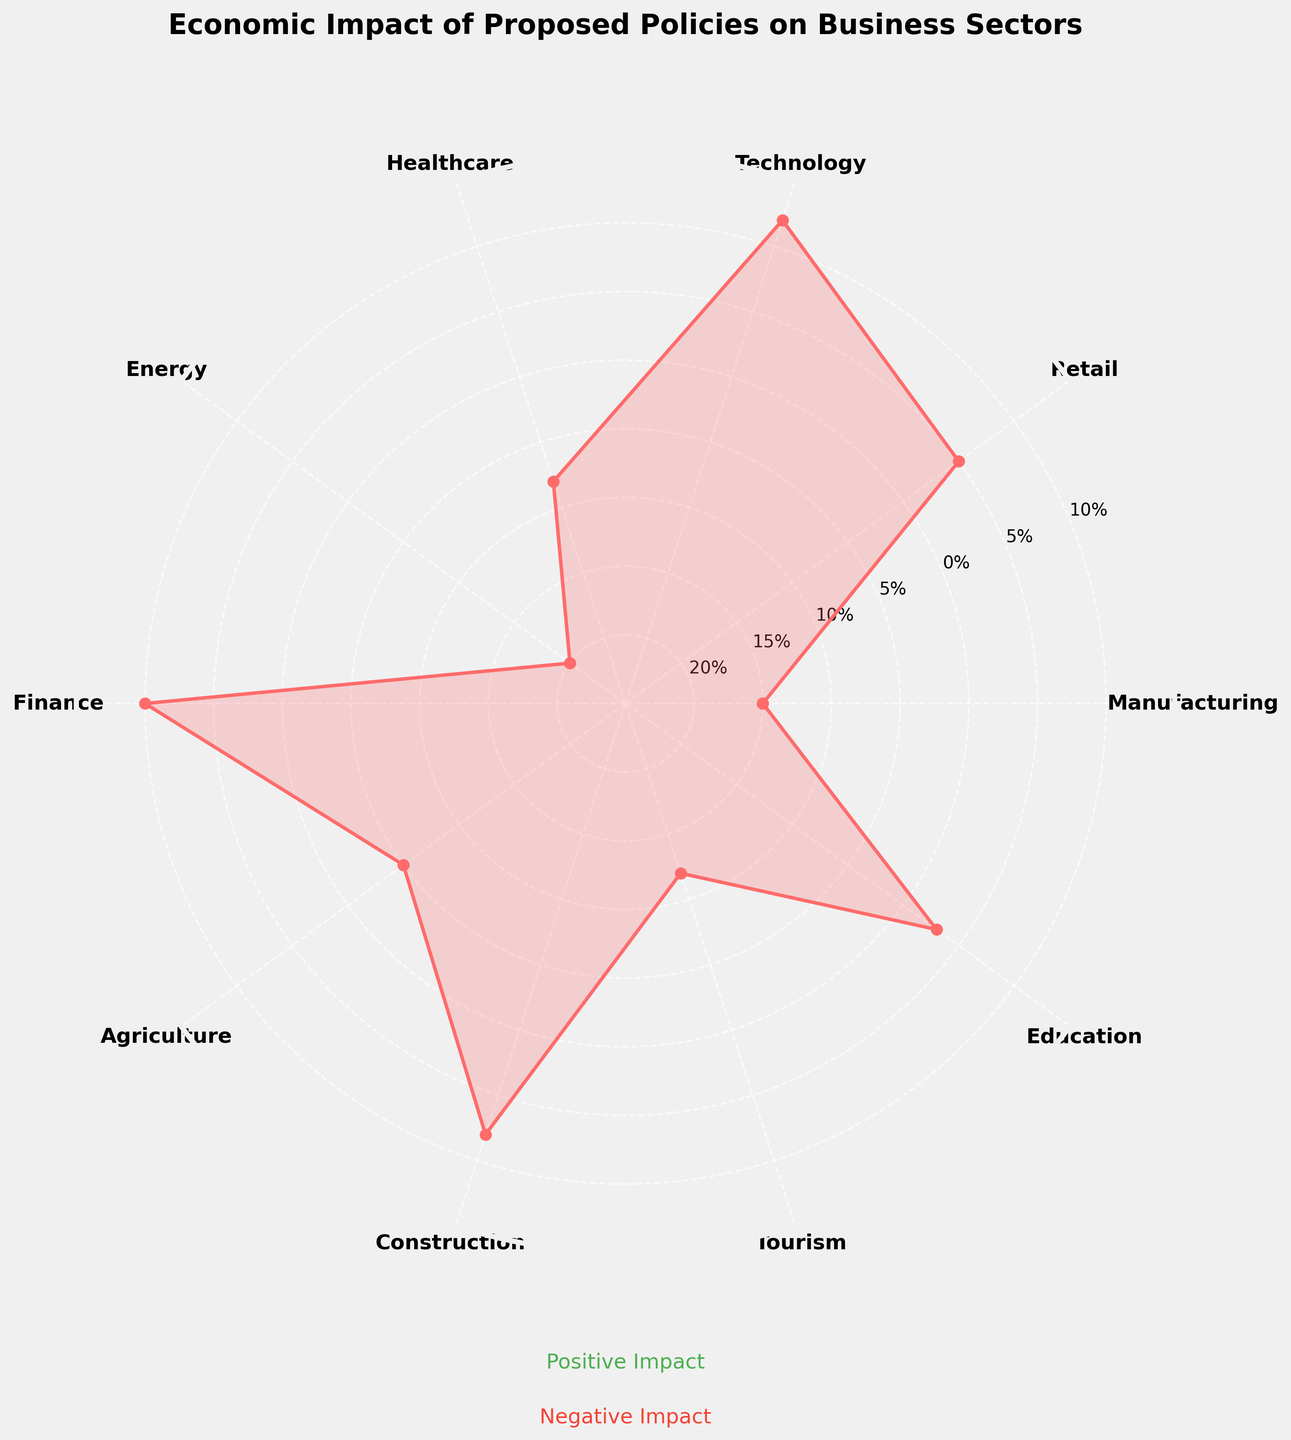What is the title of the figure? The title is usually the first item at the top of the chart. The chart title reads, "Economic Impact of Proposed Policies on Business Sectors."
Answer: Economic Impact of Proposed Policies on Business Sectors Which sector has the highest positive impact? By examining the chart, we see that the Technology sector has the highest positive impact, indicated by the highest spike in the radial plot.
Answer: Technology Which sector has the most negative impact? The Energy sector is the one with the most negative impact, identifiable by the longest dip in the radial plot.
Answer: Energy What is the negative impact of the Healthcare sector? By locating the Healthcare sector on the radial plot, we see the value associated with it reaching down to -8%.
Answer: -8% What are the positive impact sectors listed in the plot? Observing all sectors that have spikes above the radial base (0%), we find Retail, Technology, Finance, Construction, and Education.
Answer: Retail, Technology, Finance, Construction, Education Which has a greater negative impact, Tourism or Agriculture? By comparing the radial extensions of these two sectors, the Tourism sector has a greater negative impact at -12% compared to Agriculture's -5%.
Answer: Tourism What is the overall range of impacts depicted in the chart? The range is from the most positive impact to the most negative impact. The highest positive impact is +12% (Technology), and the highest negative impact is -20% (Energy), giving a total range of 32%.
Answer: 32% How many sectors experience a negative impact? Counting sectors that have impacts below the 0% base on the radial plot: Manufacturing, Healthcare, Energy, Agriculture, and Tourism.
Answer: 5 Which two sectors have the closest impact values? By comparing the impact values on the chart, Retail (5%) and Education (3%) have the closest values.
Answer: Retail and Education What is the sum of impacts of the Finance and Education sectors? The Finance sector has a positive impact of 10% and Education has 3%. Summing these impacts gives 10% + 3% = 13%.
Answer: 13% 